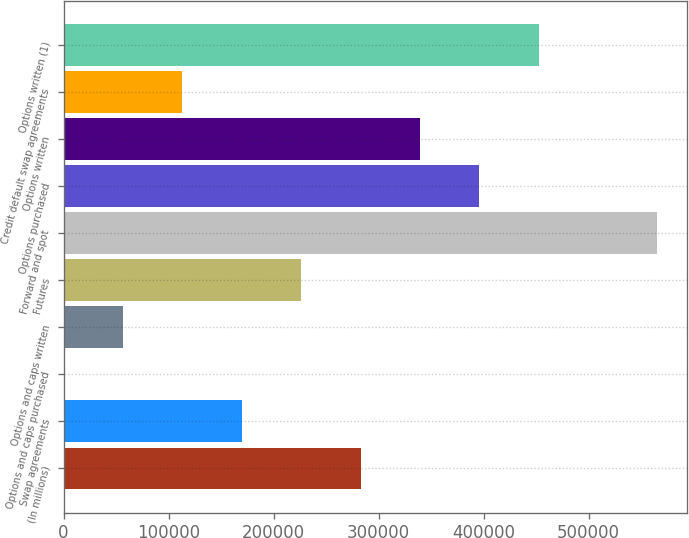Convert chart. <chart><loc_0><loc_0><loc_500><loc_500><bar_chart><fcel>(In millions)<fcel>Swap agreements<fcel>Options and caps purchased<fcel>Options and caps written<fcel>Futures<fcel>Forward and spot<fcel>Options purchased<fcel>Options written<fcel>Credit default swap agreements<fcel>Options written (1)<nl><fcel>282915<fcel>169817<fcel>169<fcel>56718.2<fcel>226366<fcel>565661<fcel>396013<fcel>339464<fcel>113267<fcel>452563<nl></chart> 